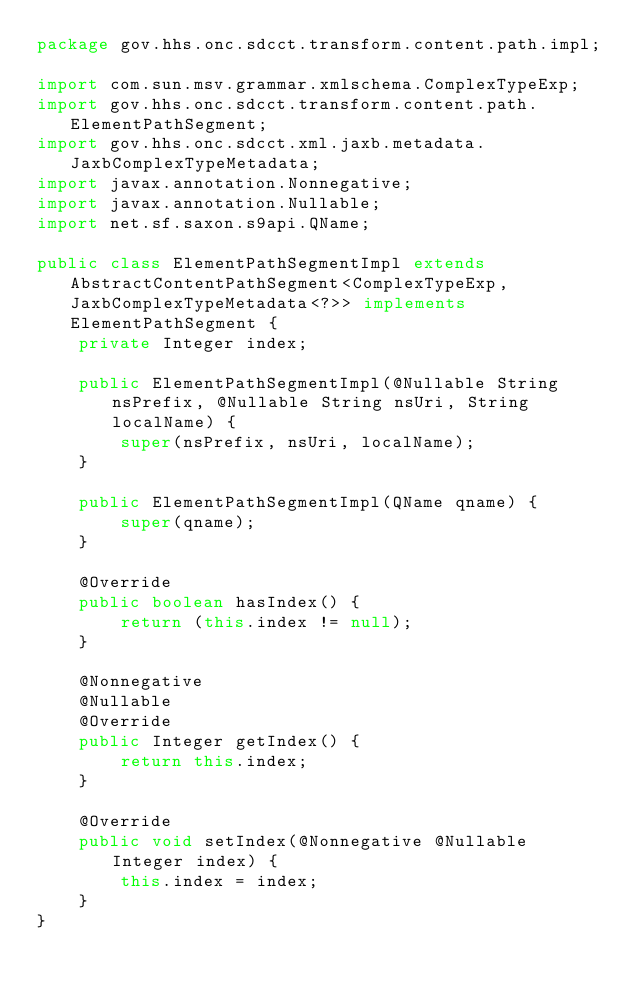<code> <loc_0><loc_0><loc_500><loc_500><_Java_>package gov.hhs.onc.sdcct.transform.content.path.impl;

import com.sun.msv.grammar.xmlschema.ComplexTypeExp;
import gov.hhs.onc.sdcct.transform.content.path.ElementPathSegment;
import gov.hhs.onc.sdcct.xml.jaxb.metadata.JaxbComplexTypeMetadata;
import javax.annotation.Nonnegative;
import javax.annotation.Nullable;
import net.sf.saxon.s9api.QName;

public class ElementPathSegmentImpl extends AbstractContentPathSegment<ComplexTypeExp, JaxbComplexTypeMetadata<?>> implements ElementPathSegment {
    private Integer index;

    public ElementPathSegmentImpl(@Nullable String nsPrefix, @Nullable String nsUri, String localName) {
        super(nsPrefix, nsUri, localName);
    }

    public ElementPathSegmentImpl(QName qname) {
        super(qname);
    }

    @Override
    public boolean hasIndex() {
        return (this.index != null);
    }

    @Nonnegative
    @Nullable
    @Override
    public Integer getIndex() {
        return this.index;
    }

    @Override
    public void setIndex(@Nonnegative @Nullable Integer index) {
        this.index = index;
    }
}
</code> 